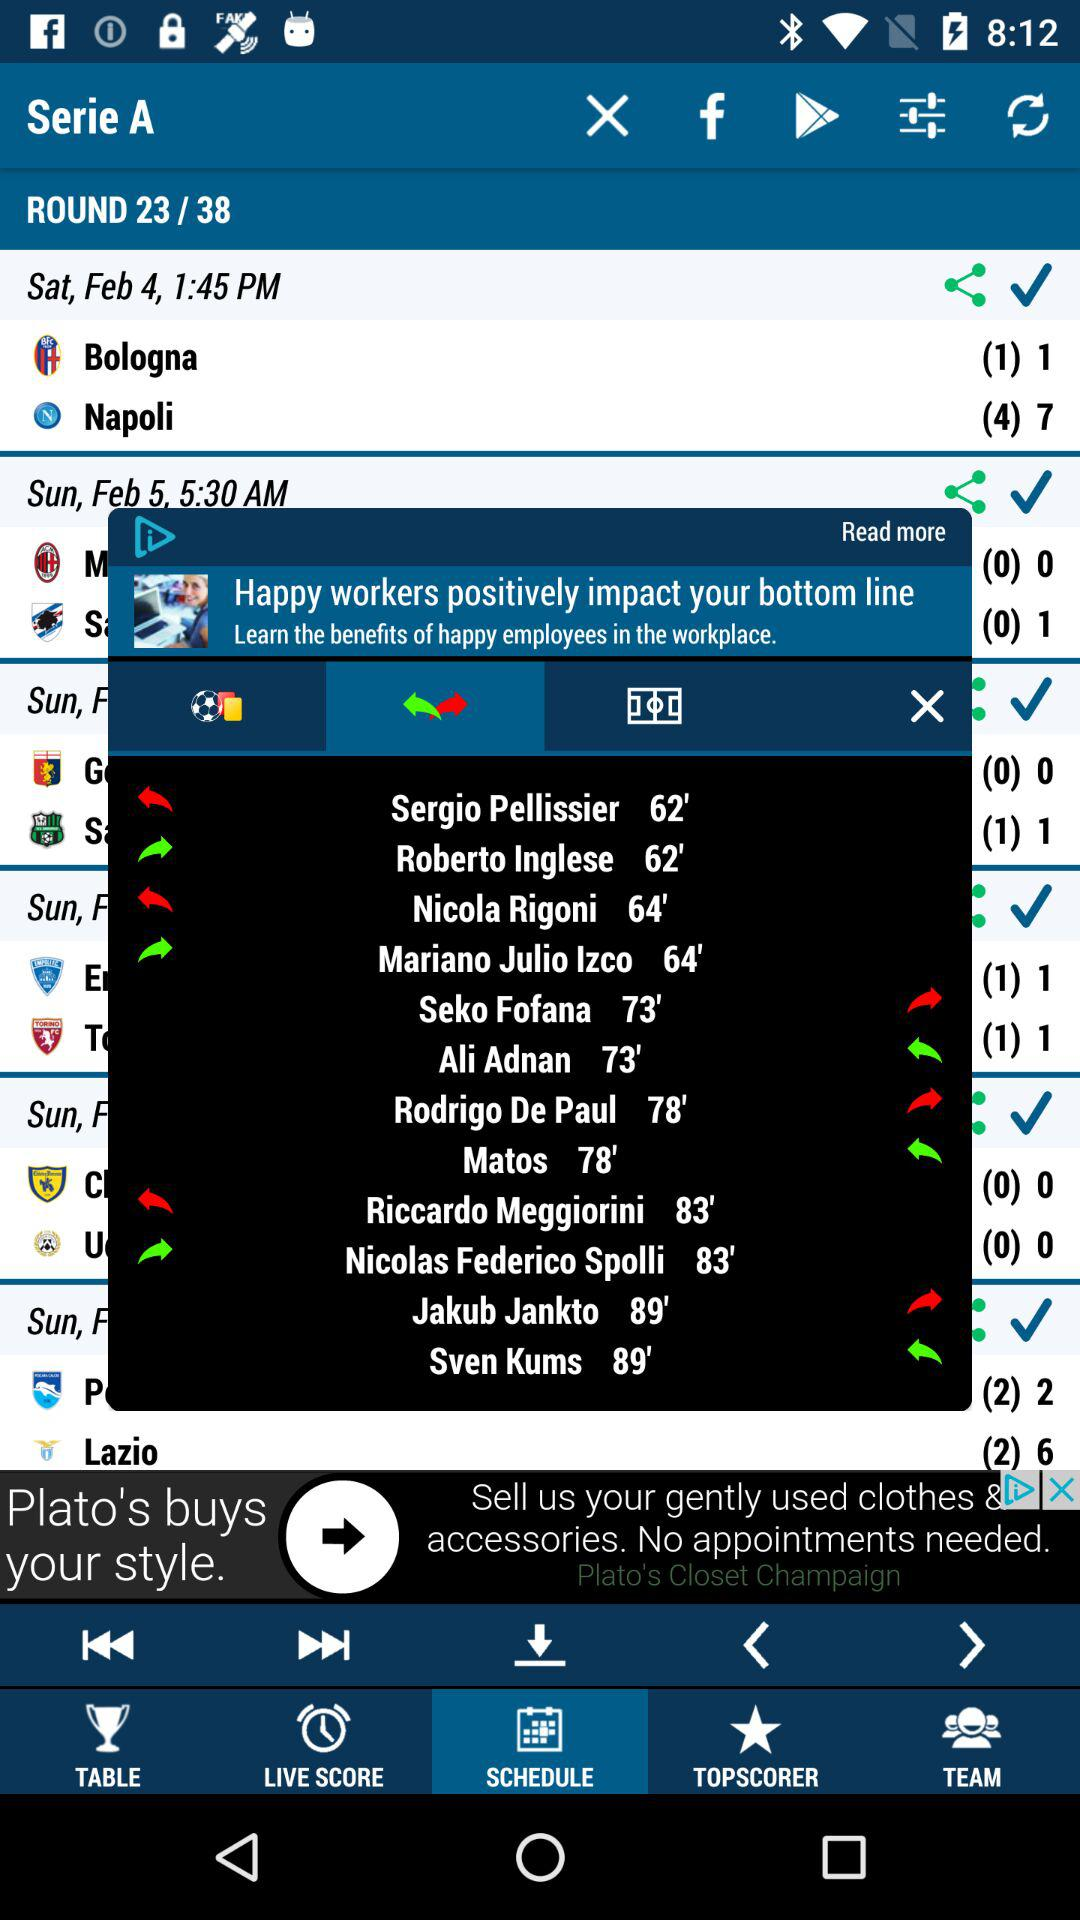How many rounds have been completed? The number of completed rounds is 23. 